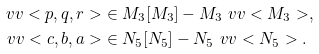<formula> <loc_0><loc_0><loc_500><loc_500>\ v v < p , q , r > & \in M _ { 3 } [ M _ { 3 } ] - M _ { 3 } \ v v < M _ { 3 } > , \\ \ v v < c , b , a > & \in { N } _ { 5 } [ { N } _ { 5 } ] - { N } _ { 5 } \ v v < { N } _ { 5 } > .</formula> 